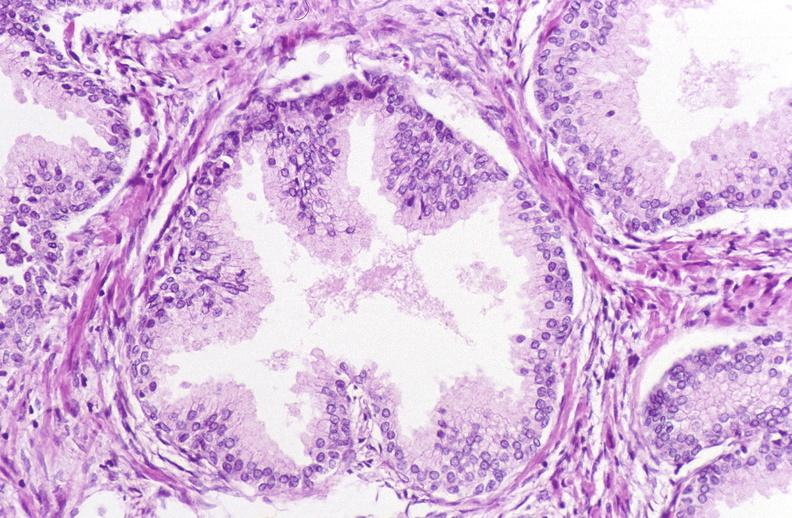what does this image show?
Answer the question using a single word or phrase. Prostate 